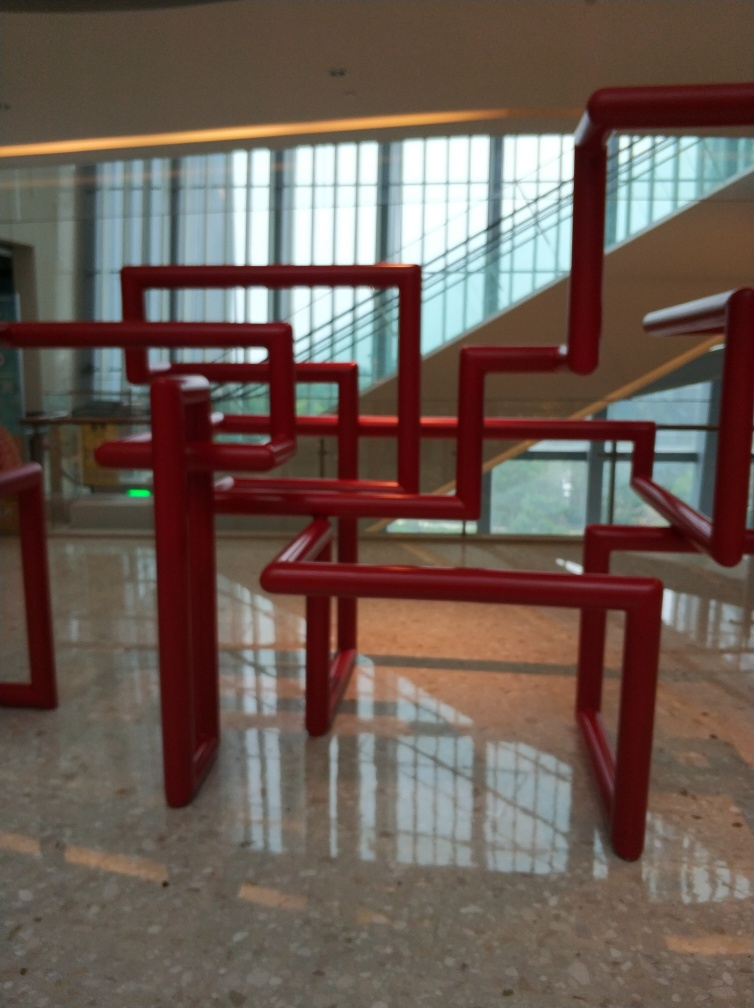What is the function of these red structures? These red structures appear to be a form of artistic installation or design element in a building, possibly serving both an aesthetic function and as part of the architecture, like railings or barriers. 